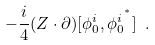Convert formula to latex. <formula><loc_0><loc_0><loc_500><loc_500>- \frac { i } { 4 } ( Z \cdot \partial ) [ \phi ^ { i } _ { 0 } , { \phi ^ { i } _ { 0 } } ^ { ^ { * } } ] \ .</formula> 